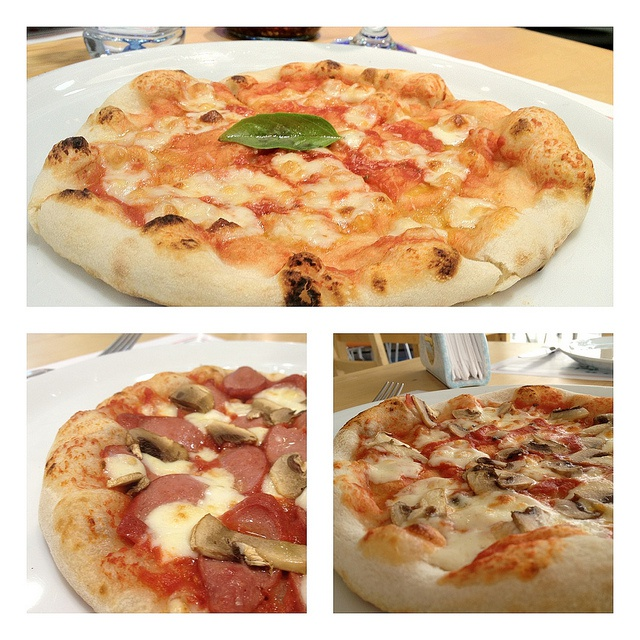Describe the objects in this image and their specific colors. I can see dining table in ivory, white, tan, and brown tones, pizza in white, orange, tan, and red tones, pizza in white, brown, tan, and gray tones, pizza in white, tan, brown, and salmon tones, and cup in white, darkgray, lightgray, tan, and gray tones in this image. 